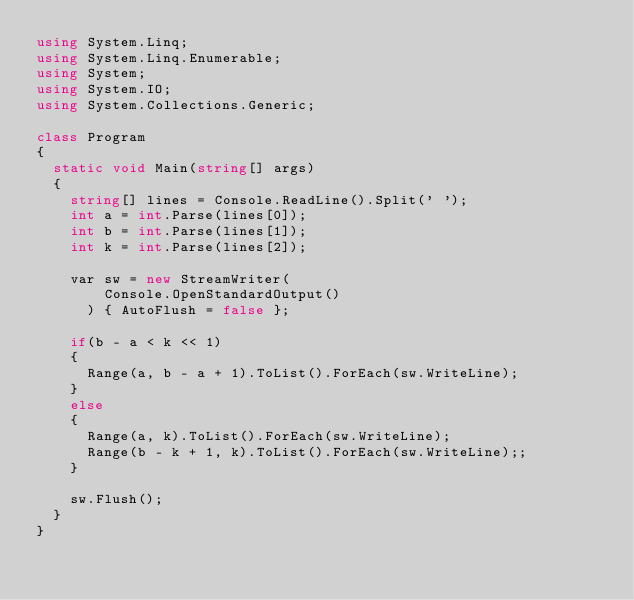<code> <loc_0><loc_0><loc_500><loc_500><_C#_>using System.Linq;
using System.Linq.Enumerable;
using System;
using System.IO;
using System.Collections.Generic;

class Program
{
  static void Main(string[] args)
  {
    string[] lines = Console.ReadLine().Split(' ');
    int a = int.Parse(lines[0]);
    int b = int.Parse(lines[1]);
    int k = int.Parse(lines[2]);

    var sw = new StreamWriter(
        Console.OpenStandardOutput()
      ) { AutoFlush = false };
      
    if(b - a < k << 1)
    {
      Range(a, b - a + 1).ToList().ForEach(sw.WriteLine);
    }
    else
    {
      Range(a, k).ToList().ForEach(sw.WriteLine);
      Range(b - k + 1, k).ToList().ForEach(sw.WriteLine);;
    }

    sw.Flush();
  }
}</code> 